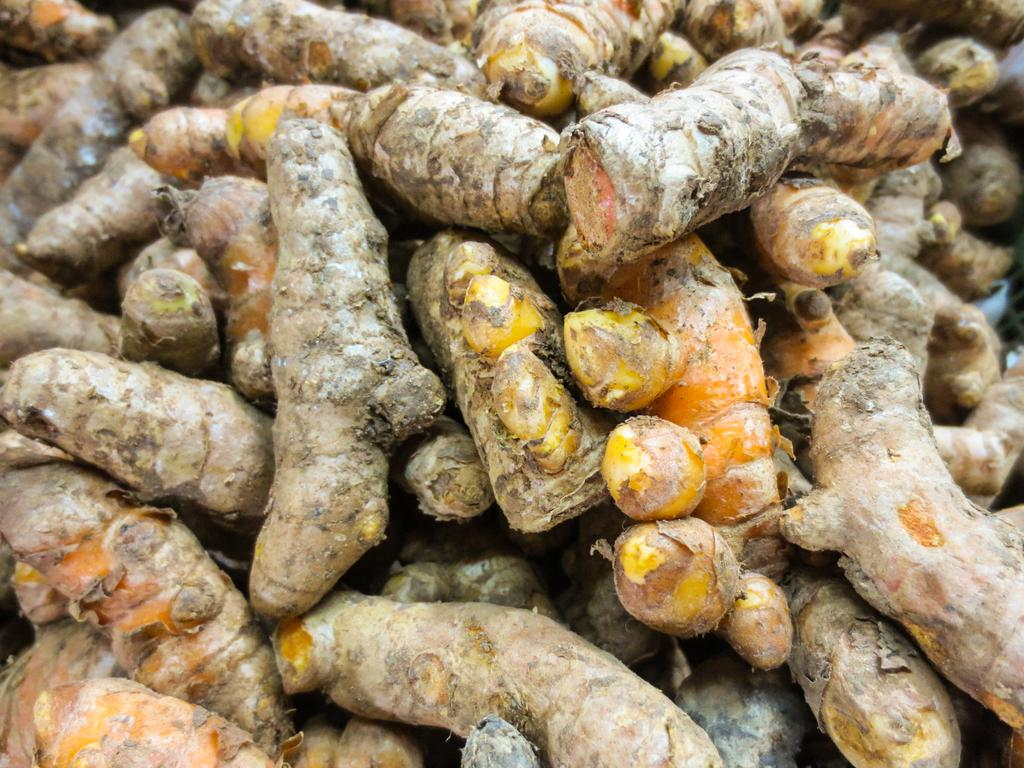What type of vegetable is present in the image? There is ginger vegetable in the image. How many friends are depicted with the ginger vegetable in the image? There are no friends present in the image; it only features the ginger vegetable. What type of feather can be seen on the ginger vegetable in the image? There is no feather present on the ginger vegetable in the image. 